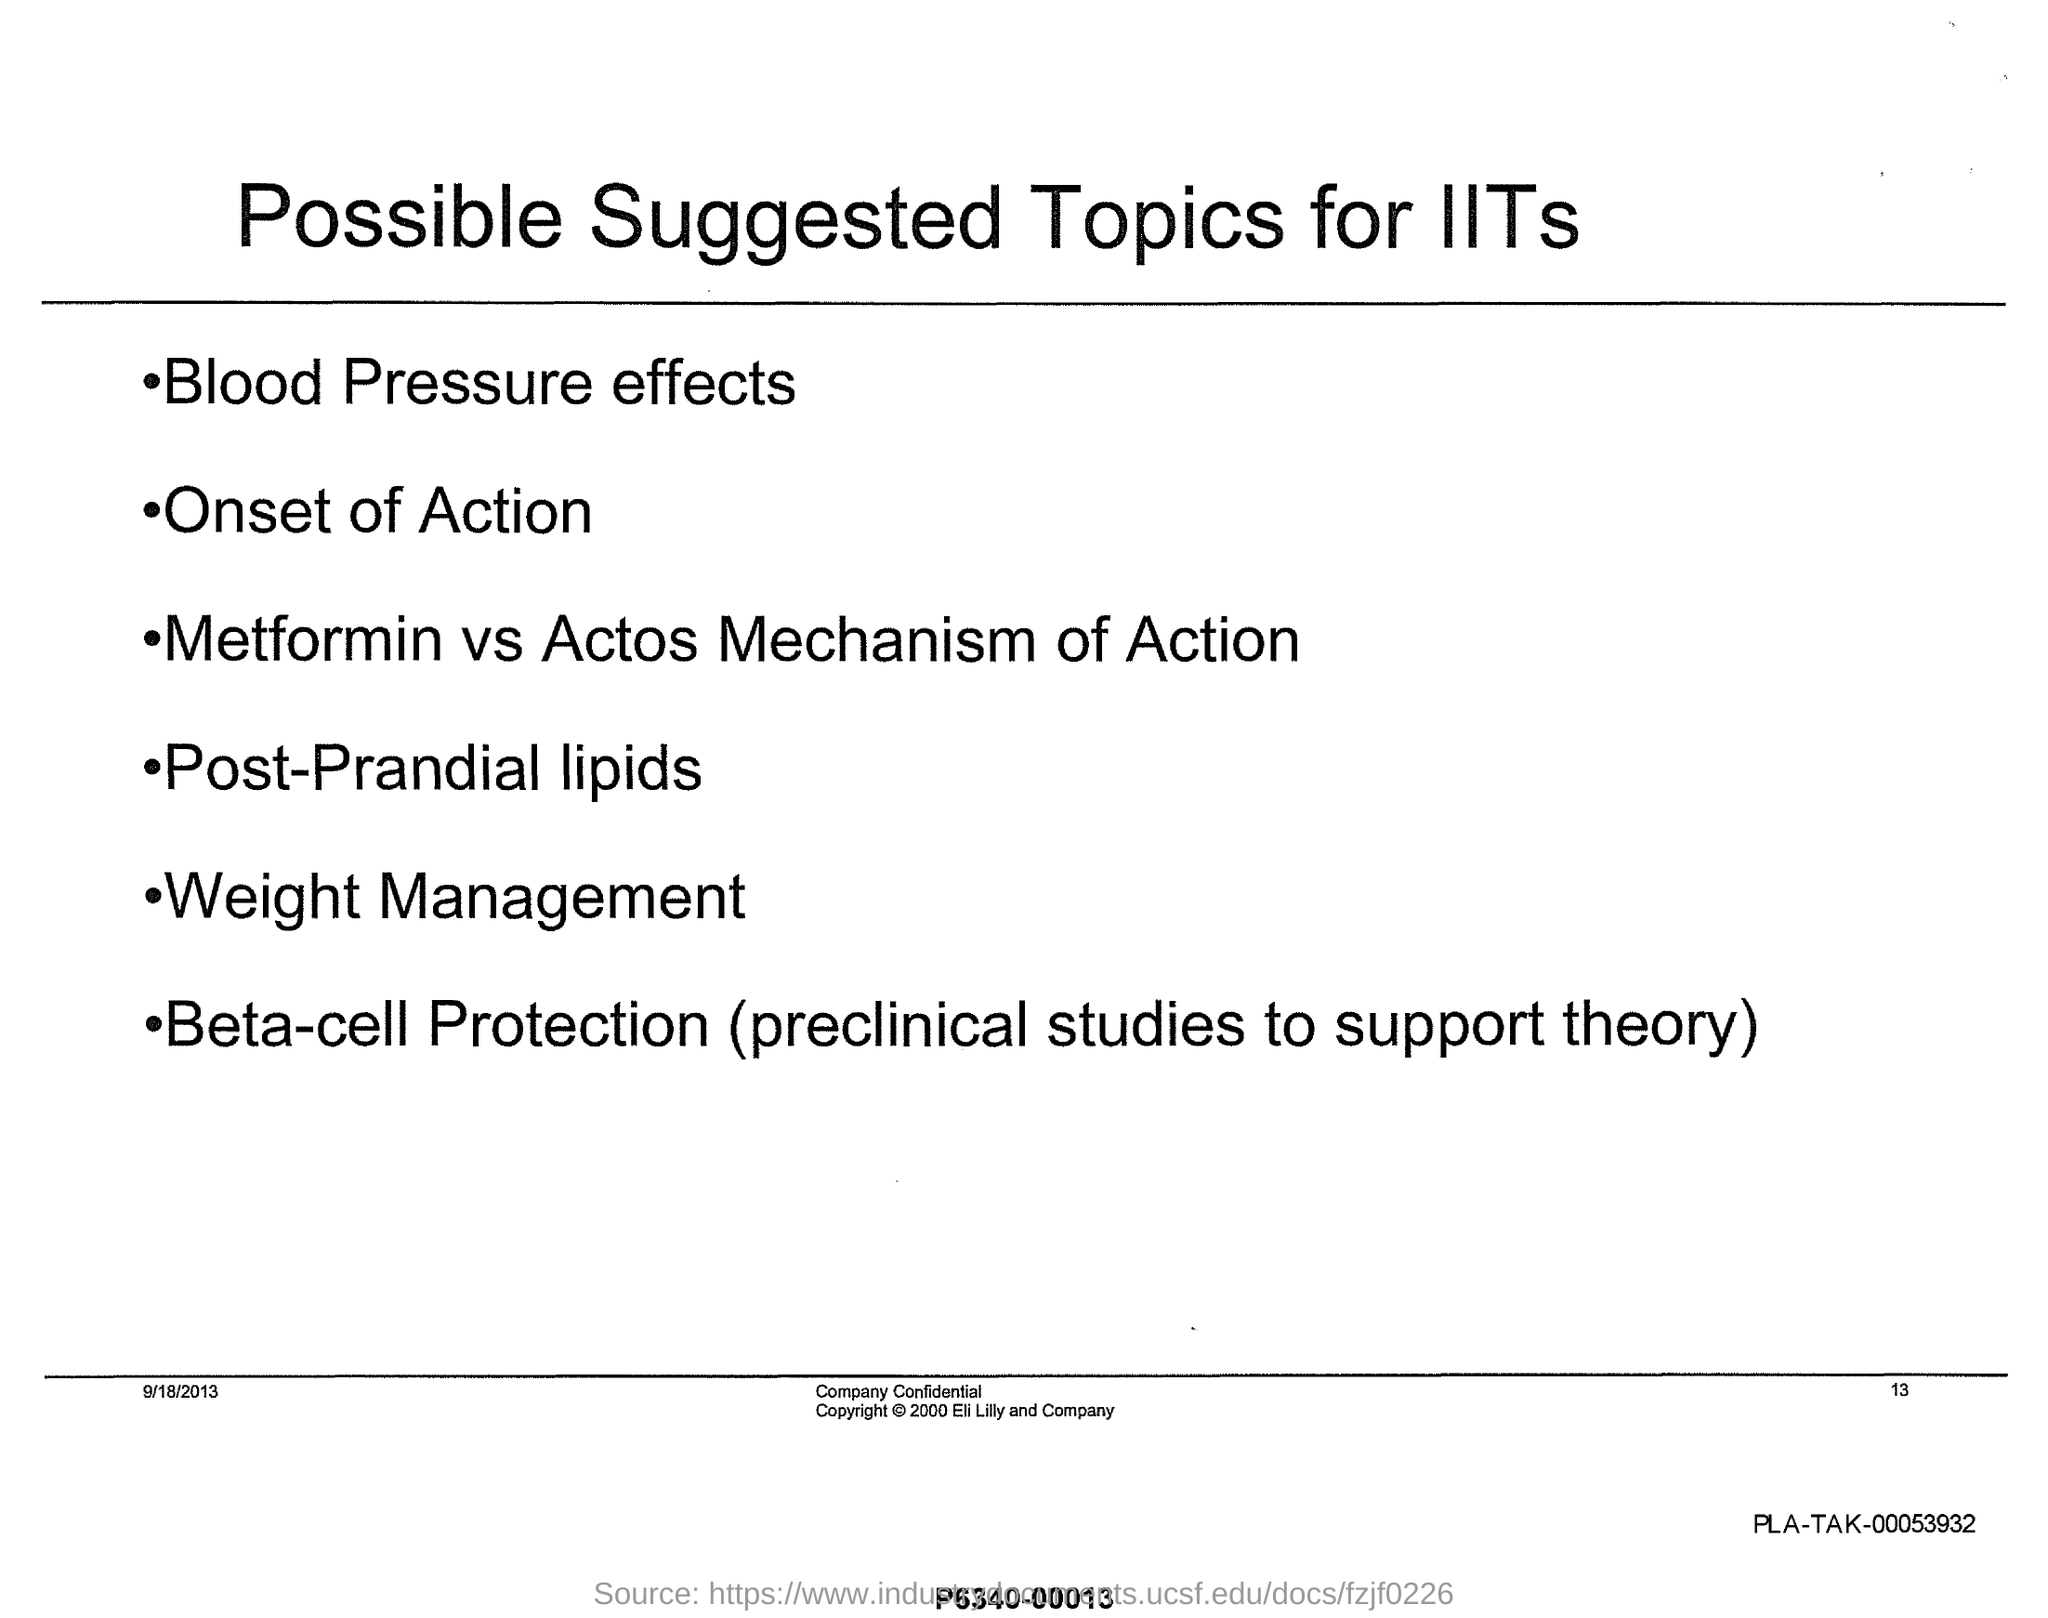Highlight a few significant elements in this photo. The possible suggested topics for IITs include blood pressure effects. This document's title is 'What is the title of this document? Possible Suggested Topics for IITs...', and it contains suggested topics for Indian Institutes of Technology. The onset of action is the second listed possible suggested topic for IITs. 